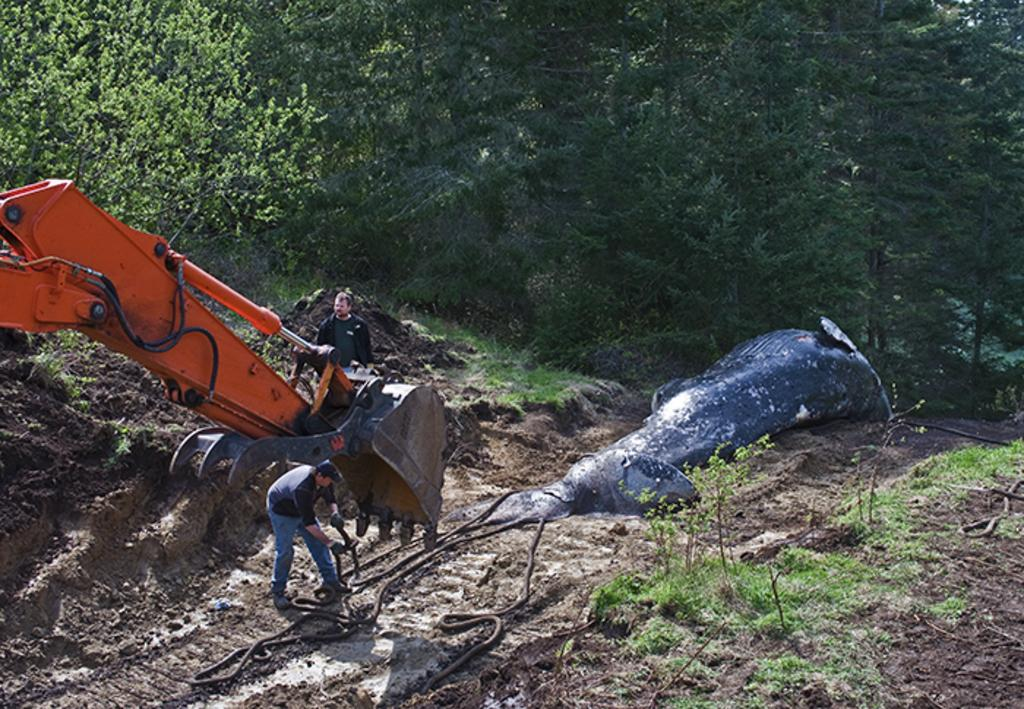How many people are in the image? There are two men in the image. What type of machinery can be seen in the image? There is an earth-moving vehicle in the image. What is the unusual object on the ground in the image? A fish is present on the ground in the image. What type of natural environment is visible in the image? There are trees visible in the image. What type of patch is visible in the sky in the image? There is no patch visible in the sky in the image. What type of toy can be seen in the hands of one of the men in the image? There is no toy present in the image; only the two men, the earth-moving vehicle, the fish, and the trees are visible. 